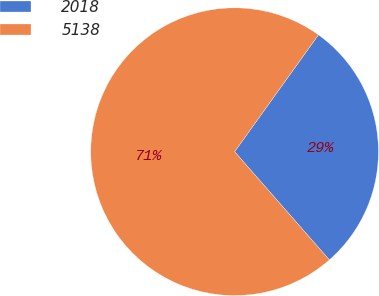Convert chart. <chart><loc_0><loc_0><loc_500><loc_500><pie_chart><fcel>2018<fcel>5138<nl><fcel>28.65%<fcel>71.35%<nl></chart> 